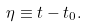<formula> <loc_0><loc_0><loc_500><loc_500>\eta \equiv t - t _ { 0 } .</formula> 